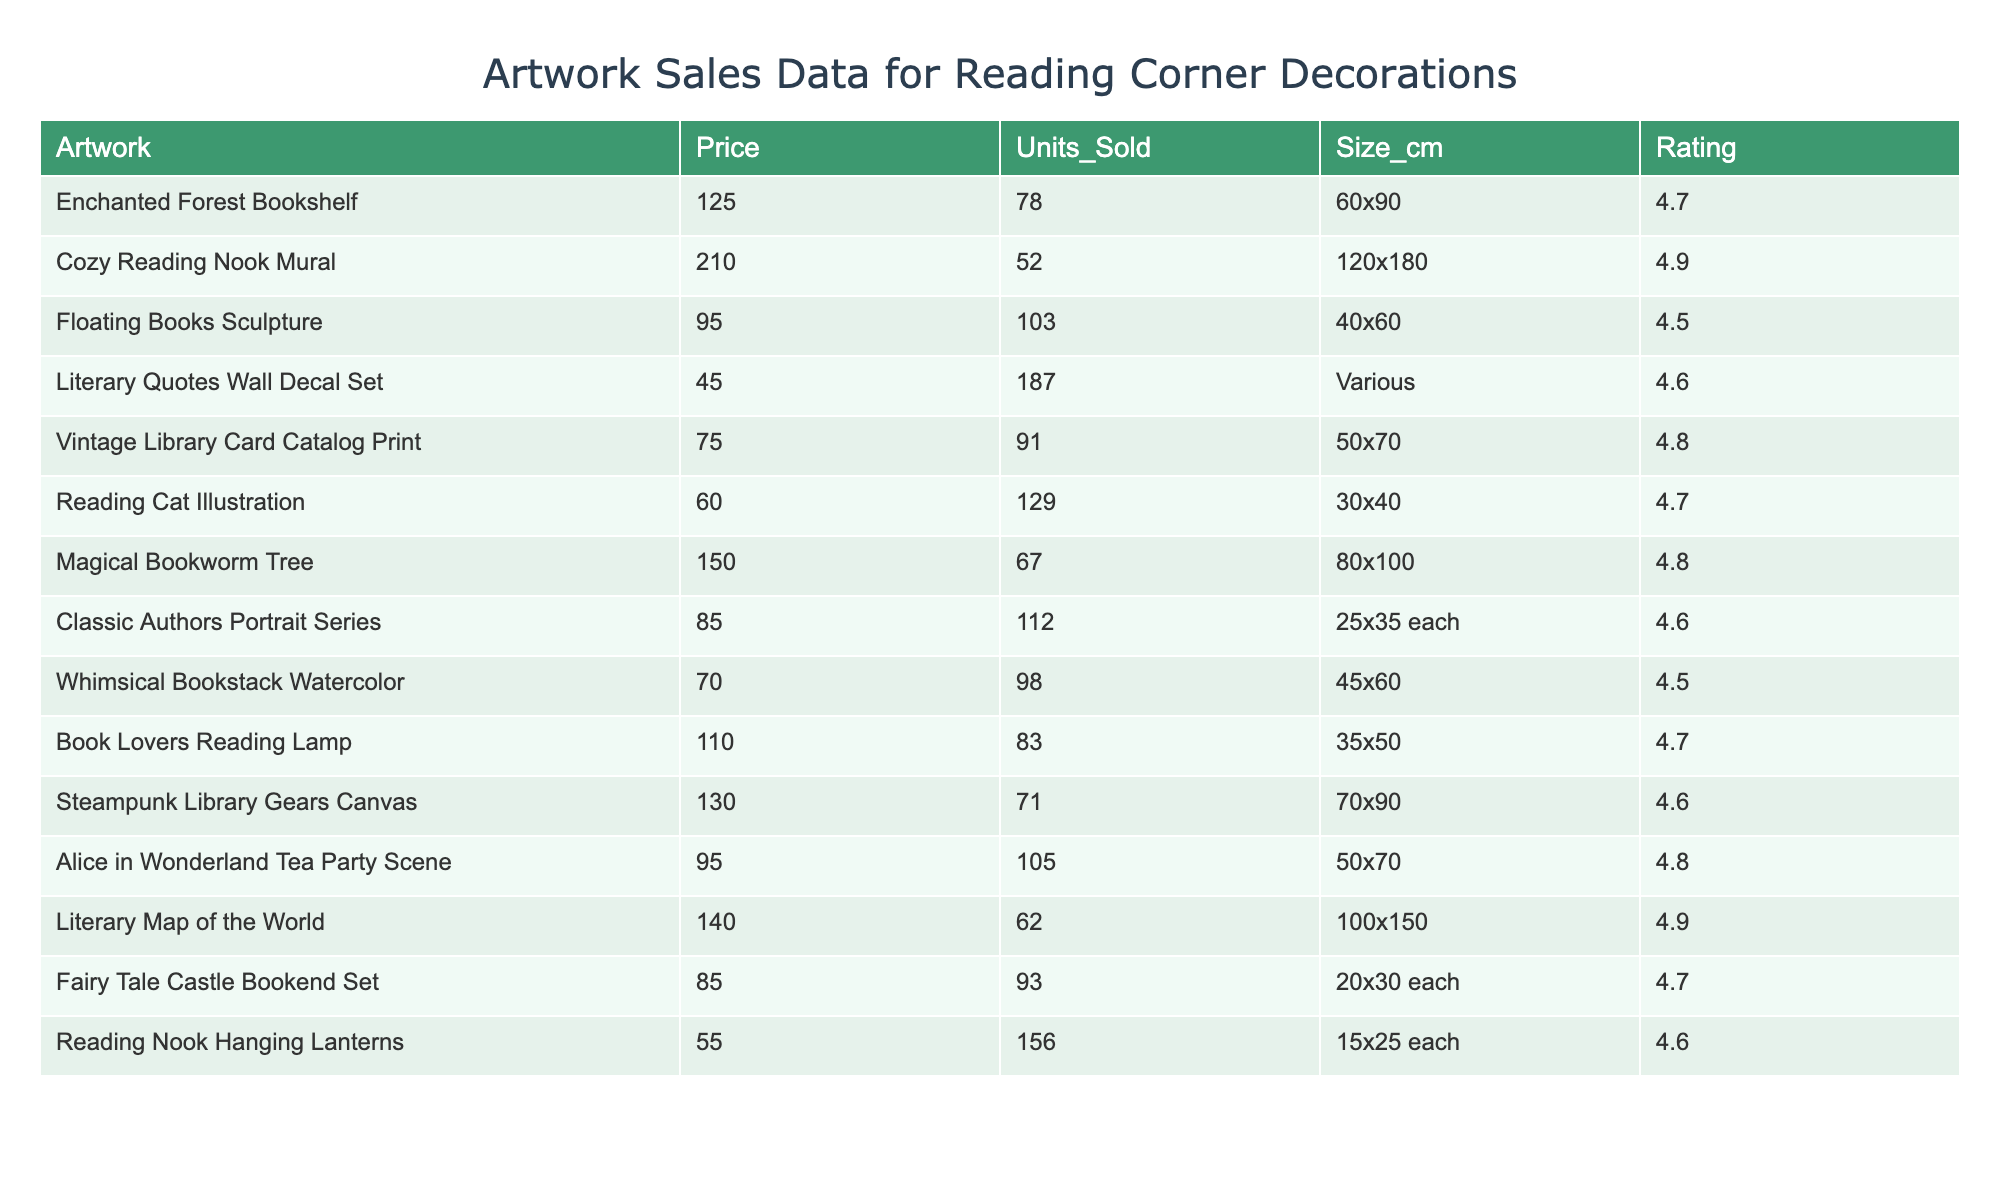What artwork has the highest rating? By examining the "Rating" column, the artwork with the highest rating is "Cozy Reading Nook Mural," which has a rating of 4.9.
Answer: Cozy Reading Nook Mural How many units were sold for the "Reading Cat Illustration"? According to the "Units_Sold" column, the "Reading Cat Illustration" sold 129 units.
Answer: 129 What is the average price of all artworks? To find the average price, first, sum all prices: (125 + 210 + 95 + 45 + 75 + 60 + 150 + 85 + 70 + 110 + 130 + 95 + 140 + 85 + 55) = 1,545. Then, divide by the number of artworks (15): 1,545 / 15 = 103.
Answer: 103 Which artwork has the lowest price and how much was it? The lowest price can be found by checking the "Price" column; the artwork with the lowest price is "Literary Quotes Wall Decal Set" at $45.
Answer: Literary Quotes Wall Decal Set, $45 What is the total number of units sold across all artworks? The total units sold can be calculated by summing all entries in the "Units_Sold" column: 78 + 52 + 103 + 187 + 91 + 129 + 67 + 112 + 98 + 83 + 71 + 105 + 62 + 93 + 156 = 1413.
Answer: 1413 Is the "Magical Bookworm Tree" more expensive than the "Vintage Library Card Catalog Print"? Comparing the "Price" of both artworks, "Magical Bookworm Tree" costs $150, and "Vintage Library Card Catalog Print" costs $75. Since 150 > 75, the answer is yes.
Answer: Yes What is the median price of the artworks? First, we need to list the prices in ascending order: [45, 55, 60, 70, 75, 85, 85, 95, 95, 110, 125, 130, 140, 150, 210]. Since there are 15 artworks, the median is the 8th value, which is $95.
Answer: 95 How many artworks have a rating of 4.7 or higher? By filtering the artworks with a rating of 4.7 or higher, we find the following artworks: "Enchanted Forest Bookshelf," "Cozy Reading Nook Mural," "Reading Cat Illustration," "Magical Bookworm Tree," "Book Lovers Reading Lamp," "Alice in Wonderland Tea Party Scene," "Fairy Tale Castle Bookend Set," and "Reading Nook Hanging Lanterns." Counting these gives us 8 artworks.
Answer: 8 What is the difference in units sold between the "Floating Books Sculpture" and the "Cozy Reading Nook Mural"? The "Floating Books Sculpture" sold 103 units and "Cozy Reading Nook Mural" sold 52 units. The difference is 103 - 52 = 51 units.
Answer: 51 Which artwork sold the most units and what is its price? By looking at the "Units_Sold" column, "Literary Quotes Wall Decal Set" sold the most units at 187 and its price is $45.
Answer: Literary Quotes Wall Decal Set, $45 